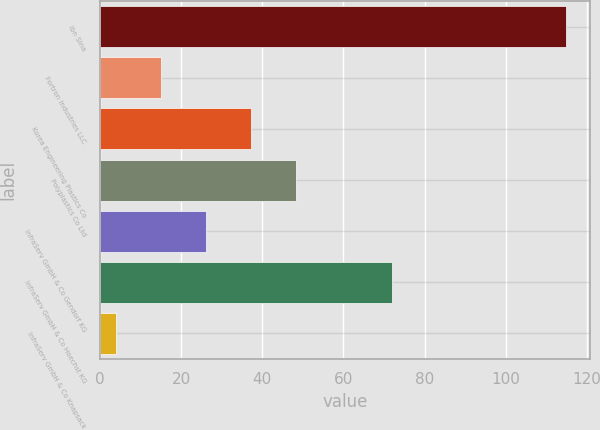Convert chart. <chart><loc_0><loc_0><loc_500><loc_500><bar_chart><fcel>Ibn Sina<fcel>Fortron Industries LLC<fcel>Korea Engineering Plastics Co<fcel>Polyplastics Co Ltd<fcel>InfraServ GmbH & Co Gendorf KG<fcel>InfraServ GmbH & Co Hoechst KG<fcel>InfraServ GmbH & Co Knapsack<nl><fcel>115<fcel>15.1<fcel>37.3<fcel>48.4<fcel>26.2<fcel>72<fcel>4<nl></chart> 